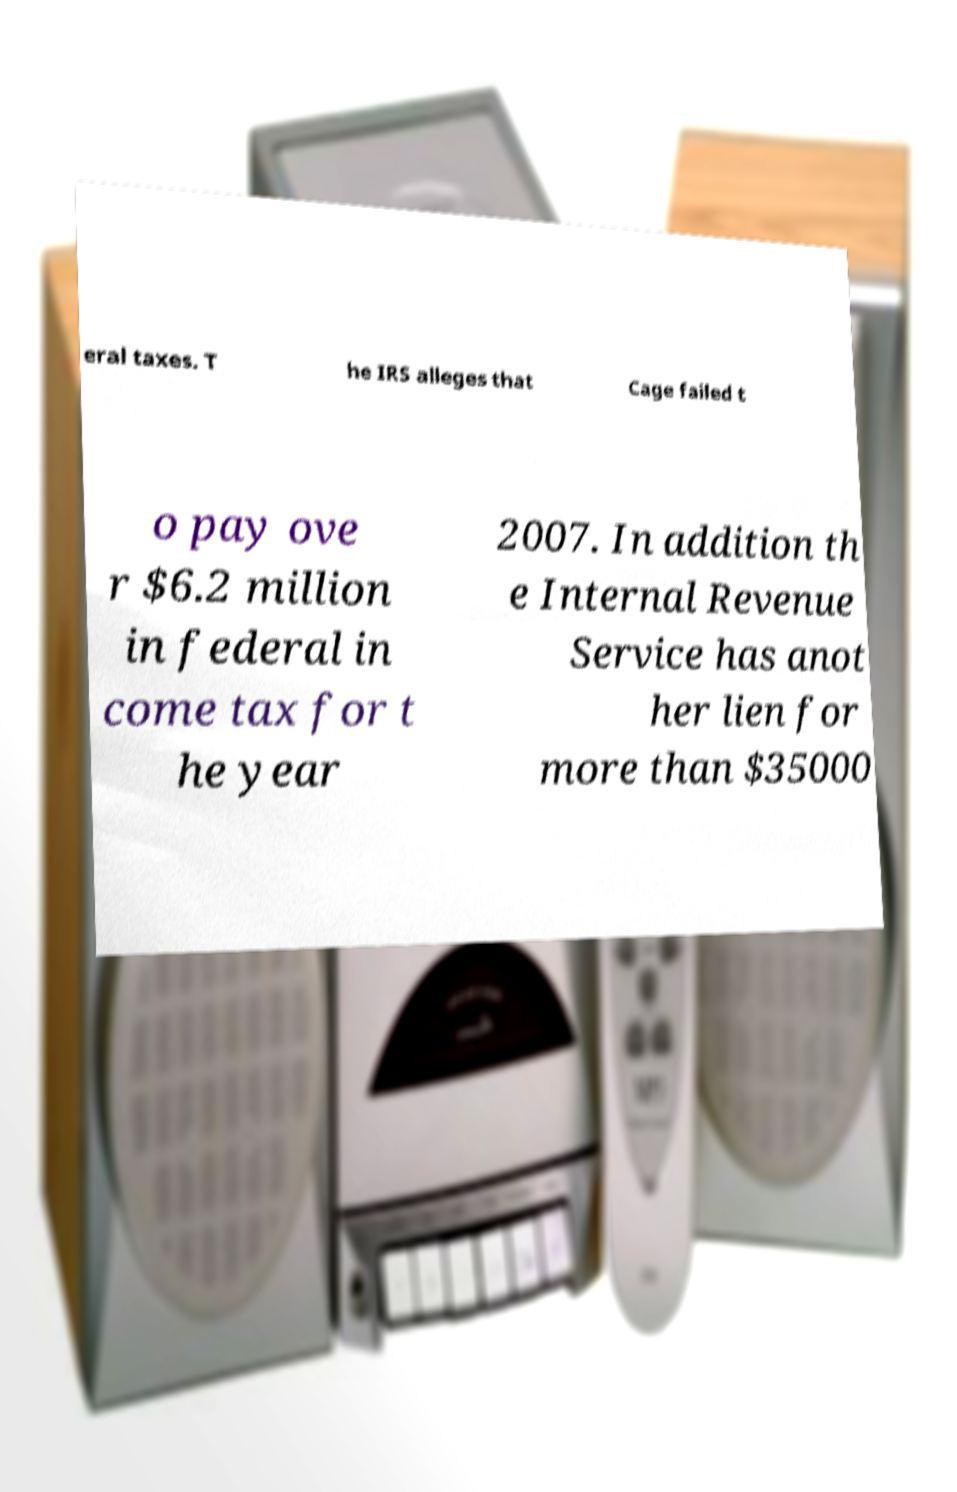What messages or text are displayed in this image? I need them in a readable, typed format. eral taxes. T he IRS alleges that Cage failed t o pay ove r $6.2 million in federal in come tax for t he year 2007. In addition th e Internal Revenue Service has anot her lien for more than $35000 